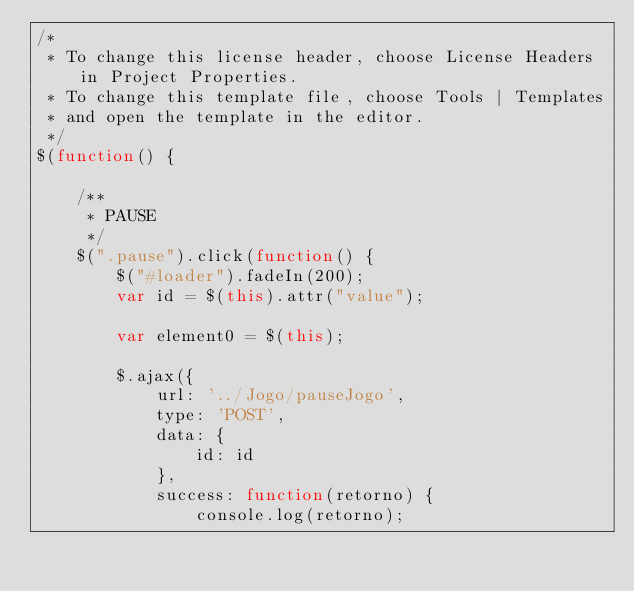<code> <loc_0><loc_0><loc_500><loc_500><_JavaScript_>/* 
 * To change this license header, choose License Headers in Project Properties.
 * To change this template file, choose Tools | Templates
 * and open the template in the editor.
 */
$(function() {

    /**
     * PAUSE
     */
    $(".pause").click(function() {
        $("#loader").fadeIn(200);
        var id = $(this).attr("value");

        var element0 = $(this);

        $.ajax({
            url: '../Jogo/pauseJogo',
            type: 'POST',
            data: {
                id: id
            },
            success: function(retorno) {
                console.log(retorno);</code> 